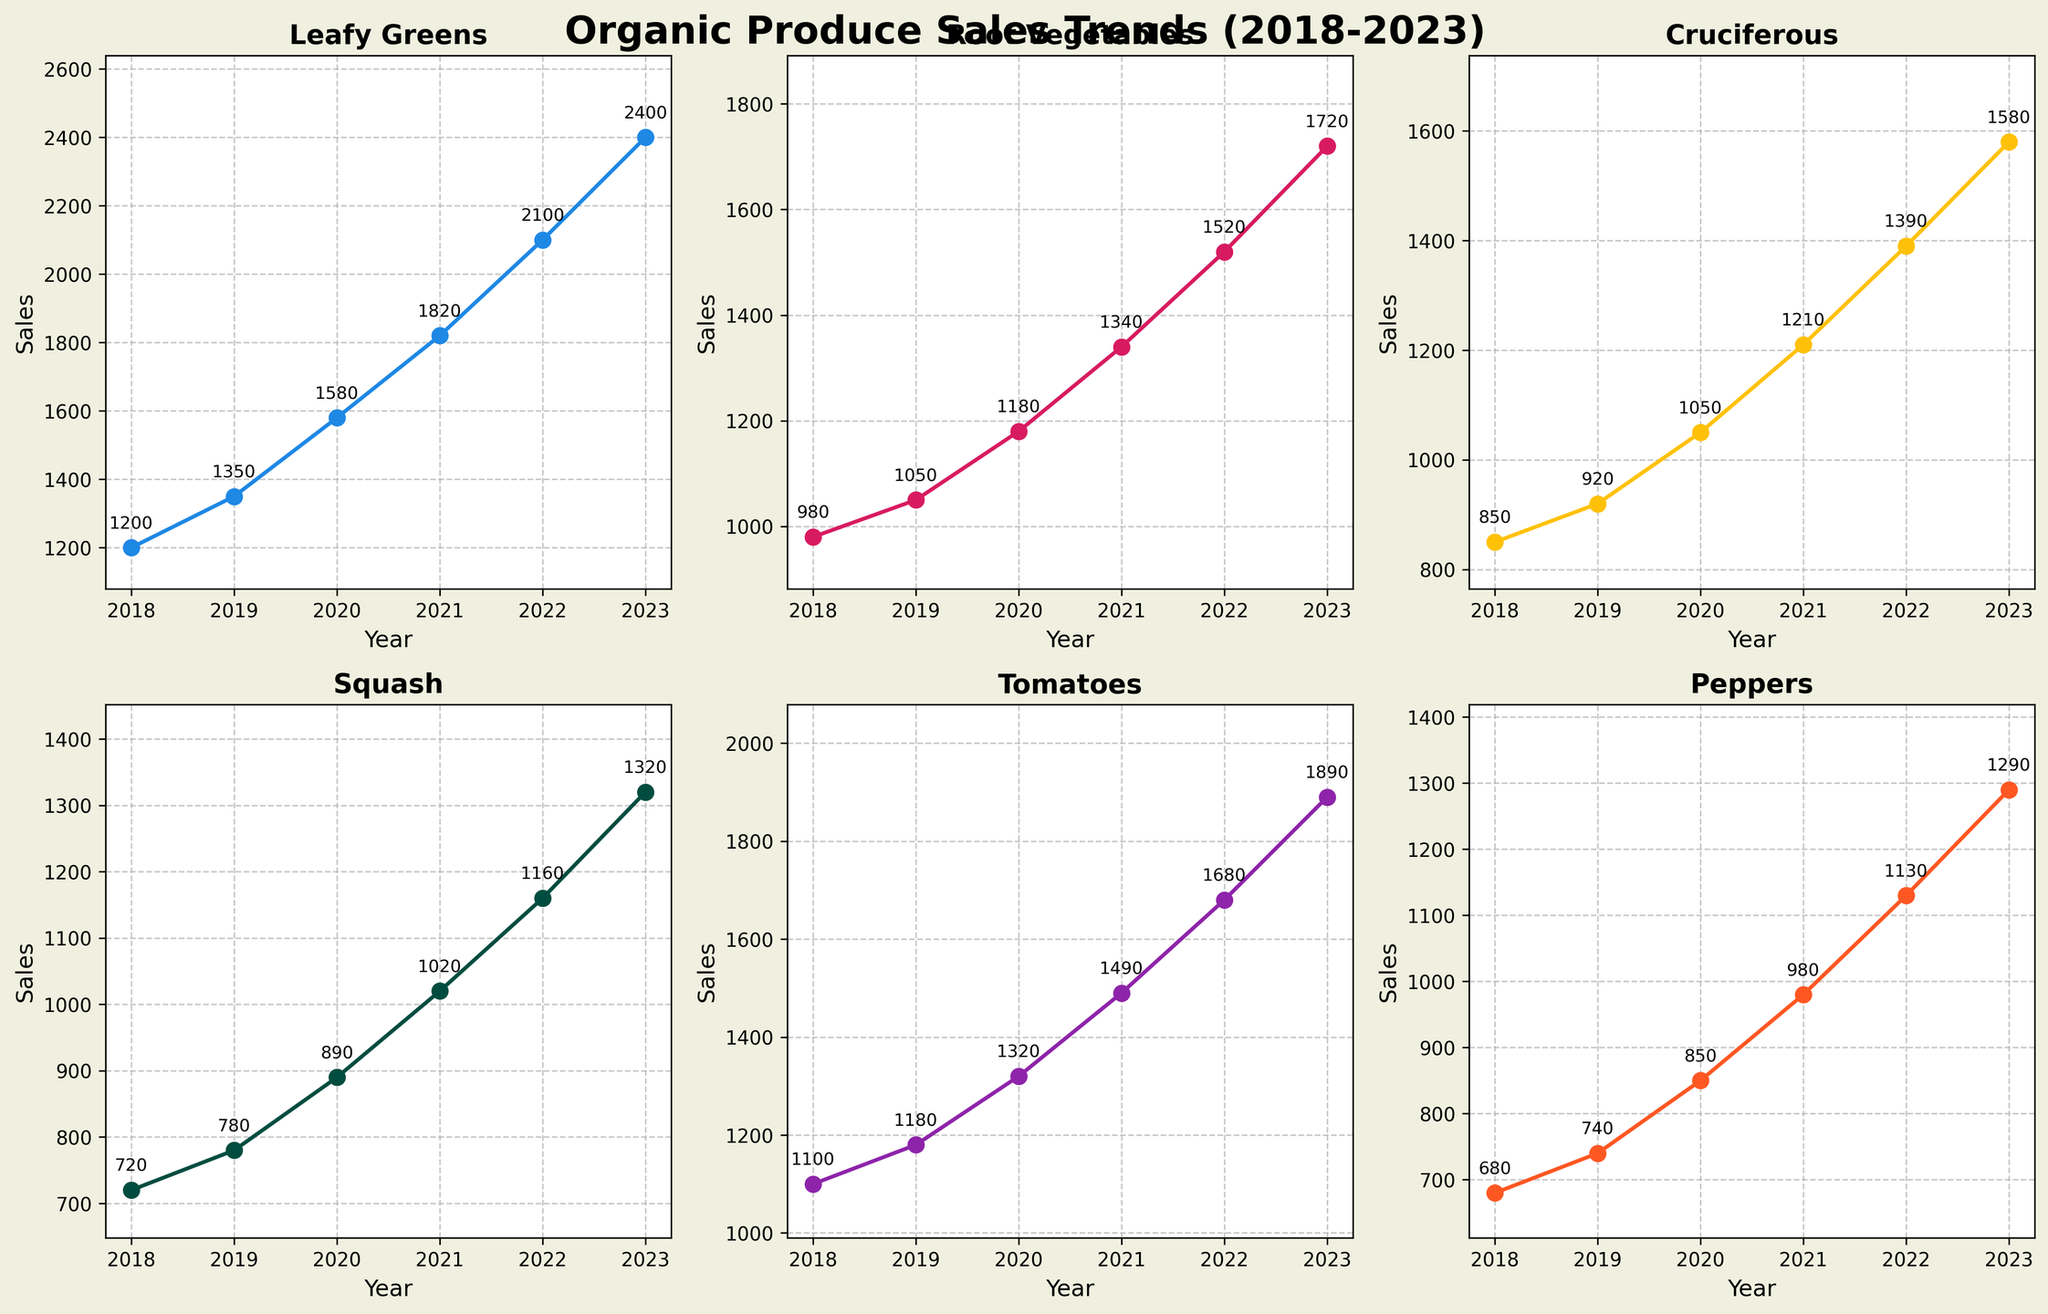What's the total sales of Leafy Greens over the five years? To find the total sales of Leafy Greens, sum up the sales values for each year: 1200 + 1350 + 1580 + 1820 + 2100 + 2400 = 10450.
Answer: 10450 Which vegetable category had the highest sales in 2023? By examining the 2023 values for each category: Leafy Greens = 2400, Root Vegetables = 1720, Cruciferous = 1580, Squash = 1320, Tomatoes = 1890, Peppers = 1290, Leafy Greens have the highest value of 2400.
Answer: Leafy Greens What is the difference in sales between Tomatoes and Peppers in 2022? Subtract the 2022 sales of Peppers from that of Tomatoes: 1680 - 1130 = 550.
Answer: 550 Which year did the Cruciferous category have the maximum growth compared to the previous year? Compare year-to-year growth: 2019-2018 = 920-850 = 70, 2020-2019 = 1050-920 = 130, 2021-2020 = 1210-1050 = 160, 2022-2021 = 1390-1210 = 180, 2023-2022 = 1580-1390 = 190. The highest growth occurs from 2022 to 2023 with an increase of 190.
Answer: 2022 to 2023 What's the overall trend in sales for Squash over the six years? The sales for Squash increase every year: 720, 780, 890, 1020, 1160, 1320. This indicates a consistent upward trend in sales over the six years.
Answer: Upward trend How does the growth rate in sales for Peppers from 2018 to 2023 compare to that for Root Vegetables in the same period? Growth rate for Peppers: (1290-680)/680 = 0.897 or 89.7%. Growth rate for Root Vegetables: (1720-980)/980 = 0.755 or 75.5%. Peppers have a higher growth rate compared to Root Vegetables.
Answer: Peppers higher Which category experienced the least total sales growth from 2018 to 2023? Compute the total growth for each category: Leafy Greens = 2400-1200 = 1200, Root Vegetables = 1720-980 = 740, Cruciferous = 1580-850 = 730, Squash = 1320-720 = 600, Tomatoes = 1890-1100 = 790, Peppers = 1290-680 = 610. The category with the least growth is Squash with 600.
Answer: Squash What is the average yearly sales for Root Vegetables from 2018 to 2023? Sum the yearly sales for Root Vegetables from 2018 to 2023 and divide by the number of years: (980 + 1050 + 1180 + 1340 + 1520 + 1720) / 6 = 7790 / 6 ≈ 1298.3.
Answer: 1298.3 In which year did Leafy Greens surpass 2000 in sales? Looking at the sales figures for Leafy Greens: 2018 = 1200, 2019 = 1350, 2020 = 1580, 2021 = 1820, 2022 = 2100, 2023 = 2400. Leafy Greens surpassed 2000 in 2022.
Answer: 2022 